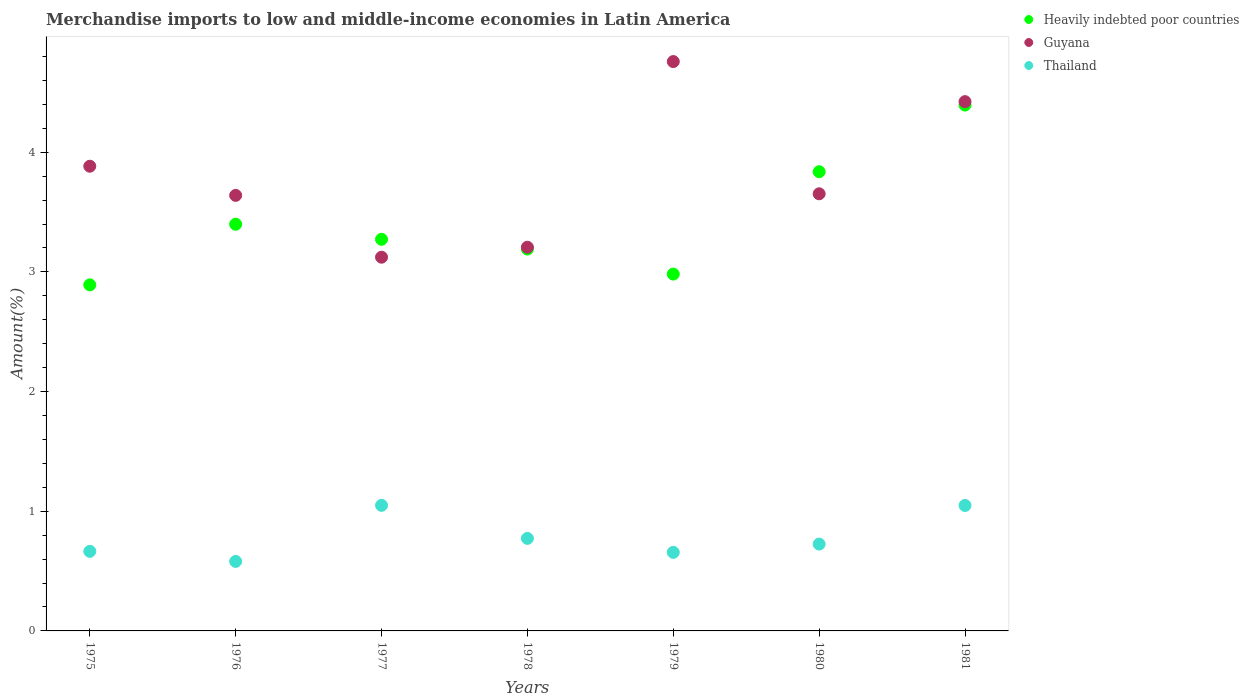How many different coloured dotlines are there?
Give a very brief answer. 3. Is the number of dotlines equal to the number of legend labels?
Ensure brevity in your answer.  Yes. What is the percentage of amount earned from merchandise imports in Heavily indebted poor countries in 1981?
Offer a terse response. 4.39. Across all years, what is the maximum percentage of amount earned from merchandise imports in Thailand?
Your answer should be compact. 1.05. Across all years, what is the minimum percentage of amount earned from merchandise imports in Thailand?
Give a very brief answer. 0.58. In which year was the percentage of amount earned from merchandise imports in Thailand maximum?
Your answer should be compact. 1977. What is the total percentage of amount earned from merchandise imports in Thailand in the graph?
Provide a short and direct response. 5.5. What is the difference between the percentage of amount earned from merchandise imports in Heavily indebted poor countries in 1979 and that in 1981?
Your answer should be very brief. -1.41. What is the difference between the percentage of amount earned from merchandise imports in Guyana in 1976 and the percentage of amount earned from merchandise imports in Thailand in 1977?
Offer a terse response. 2.59. What is the average percentage of amount earned from merchandise imports in Heavily indebted poor countries per year?
Give a very brief answer. 3.42. In the year 1979, what is the difference between the percentage of amount earned from merchandise imports in Guyana and percentage of amount earned from merchandise imports in Thailand?
Your answer should be compact. 4.1. In how many years, is the percentage of amount earned from merchandise imports in Thailand greater than 3.4 %?
Ensure brevity in your answer.  0. What is the ratio of the percentage of amount earned from merchandise imports in Thailand in 1976 to that in 1978?
Ensure brevity in your answer.  0.75. Is the percentage of amount earned from merchandise imports in Thailand in 1978 less than that in 1979?
Give a very brief answer. No. What is the difference between the highest and the second highest percentage of amount earned from merchandise imports in Thailand?
Offer a very short reply. 0. What is the difference between the highest and the lowest percentage of amount earned from merchandise imports in Guyana?
Your response must be concise. 1.63. In how many years, is the percentage of amount earned from merchandise imports in Heavily indebted poor countries greater than the average percentage of amount earned from merchandise imports in Heavily indebted poor countries taken over all years?
Provide a short and direct response. 2. Is the sum of the percentage of amount earned from merchandise imports in Guyana in 1978 and 1980 greater than the maximum percentage of amount earned from merchandise imports in Heavily indebted poor countries across all years?
Your answer should be very brief. Yes. Is the percentage of amount earned from merchandise imports in Heavily indebted poor countries strictly greater than the percentage of amount earned from merchandise imports in Thailand over the years?
Give a very brief answer. Yes. Is the percentage of amount earned from merchandise imports in Guyana strictly less than the percentage of amount earned from merchandise imports in Heavily indebted poor countries over the years?
Provide a succinct answer. No. How many dotlines are there?
Ensure brevity in your answer.  3. How many years are there in the graph?
Your answer should be very brief. 7. Are the values on the major ticks of Y-axis written in scientific E-notation?
Make the answer very short. No. Does the graph contain grids?
Offer a terse response. No. Where does the legend appear in the graph?
Provide a succinct answer. Top right. How many legend labels are there?
Your response must be concise. 3. What is the title of the graph?
Provide a short and direct response. Merchandise imports to low and middle-income economies in Latin America. What is the label or title of the X-axis?
Provide a short and direct response. Years. What is the label or title of the Y-axis?
Provide a short and direct response. Amount(%). What is the Amount(%) in Heavily indebted poor countries in 1975?
Provide a short and direct response. 2.89. What is the Amount(%) of Guyana in 1975?
Provide a short and direct response. 3.88. What is the Amount(%) in Thailand in 1975?
Provide a succinct answer. 0.66. What is the Amount(%) in Heavily indebted poor countries in 1976?
Provide a succinct answer. 3.4. What is the Amount(%) in Guyana in 1976?
Give a very brief answer. 3.64. What is the Amount(%) in Thailand in 1976?
Give a very brief answer. 0.58. What is the Amount(%) in Heavily indebted poor countries in 1977?
Provide a short and direct response. 3.27. What is the Amount(%) in Guyana in 1977?
Your response must be concise. 3.12. What is the Amount(%) of Thailand in 1977?
Offer a very short reply. 1.05. What is the Amount(%) of Heavily indebted poor countries in 1978?
Ensure brevity in your answer.  3.19. What is the Amount(%) of Guyana in 1978?
Ensure brevity in your answer.  3.21. What is the Amount(%) of Thailand in 1978?
Your answer should be compact. 0.77. What is the Amount(%) of Heavily indebted poor countries in 1979?
Give a very brief answer. 2.98. What is the Amount(%) of Guyana in 1979?
Provide a succinct answer. 4.76. What is the Amount(%) in Thailand in 1979?
Your response must be concise. 0.66. What is the Amount(%) in Heavily indebted poor countries in 1980?
Provide a succinct answer. 3.84. What is the Amount(%) in Guyana in 1980?
Your response must be concise. 3.65. What is the Amount(%) in Thailand in 1980?
Ensure brevity in your answer.  0.73. What is the Amount(%) in Heavily indebted poor countries in 1981?
Offer a terse response. 4.39. What is the Amount(%) of Guyana in 1981?
Keep it short and to the point. 4.42. What is the Amount(%) of Thailand in 1981?
Give a very brief answer. 1.05. Across all years, what is the maximum Amount(%) of Heavily indebted poor countries?
Provide a succinct answer. 4.39. Across all years, what is the maximum Amount(%) in Guyana?
Provide a short and direct response. 4.76. Across all years, what is the maximum Amount(%) in Thailand?
Give a very brief answer. 1.05. Across all years, what is the minimum Amount(%) in Heavily indebted poor countries?
Ensure brevity in your answer.  2.89. Across all years, what is the minimum Amount(%) of Guyana?
Make the answer very short. 3.12. Across all years, what is the minimum Amount(%) in Thailand?
Your response must be concise. 0.58. What is the total Amount(%) of Heavily indebted poor countries in the graph?
Offer a terse response. 23.97. What is the total Amount(%) of Guyana in the graph?
Your answer should be compact. 26.69. What is the total Amount(%) of Thailand in the graph?
Your answer should be compact. 5.5. What is the difference between the Amount(%) in Heavily indebted poor countries in 1975 and that in 1976?
Offer a terse response. -0.51. What is the difference between the Amount(%) in Guyana in 1975 and that in 1976?
Provide a succinct answer. 0.24. What is the difference between the Amount(%) of Thailand in 1975 and that in 1976?
Offer a terse response. 0.08. What is the difference between the Amount(%) of Heavily indebted poor countries in 1975 and that in 1977?
Your response must be concise. -0.38. What is the difference between the Amount(%) of Guyana in 1975 and that in 1977?
Offer a terse response. 0.76. What is the difference between the Amount(%) in Thailand in 1975 and that in 1977?
Your response must be concise. -0.38. What is the difference between the Amount(%) in Heavily indebted poor countries in 1975 and that in 1978?
Your answer should be very brief. -0.3. What is the difference between the Amount(%) in Guyana in 1975 and that in 1978?
Offer a very short reply. 0.68. What is the difference between the Amount(%) in Thailand in 1975 and that in 1978?
Provide a short and direct response. -0.11. What is the difference between the Amount(%) in Heavily indebted poor countries in 1975 and that in 1979?
Your response must be concise. -0.09. What is the difference between the Amount(%) in Guyana in 1975 and that in 1979?
Your response must be concise. -0.87. What is the difference between the Amount(%) of Thailand in 1975 and that in 1979?
Keep it short and to the point. 0.01. What is the difference between the Amount(%) in Heavily indebted poor countries in 1975 and that in 1980?
Your answer should be very brief. -0.95. What is the difference between the Amount(%) in Guyana in 1975 and that in 1980?
Offer a very short reply. 0.23. What is the difference between the Amount(%) in Thailand in 1975 and that in 1980?
Provide a succinct answer. -0.06. What is the difference between the Amount(%) of Heavily indebted poor countries in 1975 and that in 1981?
Your response must be concise. -1.5. What is the difference between the Amount(%) in Guyana in 1975 and that in 1981?
Your answer should be compact. -0.54. What is the difference between the Amount(%) of Thailand in 1975 and that in 1981?
Your answer should be very brief. -0.38. What is the difference between the Amount(%) in Heavily indebted poor countries in 1976 and that in 1977?
Ensure brevity in your answer.  0.13. What is the difference between the Amount(%) in Guyana in 1976 and that in 1977?
Your answer should be compact. 0.52. What is the difference between the Amount(%) of Thailand in 1976 and that in 1977?
Ensure brevity in your answer.  -0.47. What is the difference between the Amount(%) in Heavily indebted poor countries in 1976 and that in 1978?
Provide a succinct answer. 0.21. What is the difference between the Amount(%) of Guyana in 1976 and that in 1978?
Your response must be concise. 0.43. What is the difference between the Amount(%) in Thailand in 1976 and that in 1978?
Your answer should be very brief. -0.19. What is the difference between the Amount(%) of Heavily indebted poor countries in 1976 and that in 1979?
Keep it short and to the point. 0.42. What is the difference between the Amount(%) in Guyana in 1976 and that in 1979?
Offer a terse response. -1.12. What is the difference between the Amount(%) in Thailand in 1976 and that in 1979?
Provide a succinct answer. -0.08. What is the difference between the Amount(%) in Heavily indebted poor countries in 1976 and that in 1980?
Your response must be concise. -0.44. What is the difference between the Amount(%) of Guyana in 1976 and that in 1980?
Give a very brief answer. -0.01. What is the difference between the Amount(%) in Thailand in 1976 and that in 1980?
Give a very brief answer. -0.14. What is the difference between the Amount(%) of Heavily indebted poor countries in 1976 and that in 1981?
Your answer should be very brief. -1. What is the difference between the Amount(%) of Guyana in 1976 and that in 1981?
Your response must be concise. -0.78. What is the difference between the Amount(%) in Thailand in 1976 and that in 1981?
Provide a short and direct response. -0.47. What is the difference between the Amount(%) of Heavily indebted poor countries in 1977 and that in 1978?
Make the answer very short. 0.08. What is the difference between the Amount(%) of Guyana in 1977 and that in 1978?
Your answer should be compact. -0.08. What is the difference between the Amount(%) in Thailand in 1977 and that in 1978?
Offer a terse response. 0.28. What is the difference between the Amount(%) of Heavily indebted poor countries in 1977 and that in 1979?
Make the answer very short. 0.29. What is the difference between the Amount(%) in Guyana in 1977 and that in 1979?
Offer a very short reply. -1.63. What is the difference between the Amount(%) in Thailand in 1977 and that in 1979?
Keep it short and to the point. 0.39. What is the difference between the Amount(%) in Heavily indebted poor countries in 1977 and that in 1980?
Give a very brief answer. -0.56. What is the difference between the Amount(%) of Guyana in 1977 and that in 1980?
Offer a terse response. -0.53. What is the difference between the Amount(%) in Thailand in 1977 and that in 1980?
Your answer should be very brief. 0.32. What is the difference between the Amount(%) in Heavily indebted poor countries in 1977 and that in 1981?
Ensure brevity in your answer.  -1.12. What is the difference between the Amount(%) of Guyana in 1977 and that in 1981?
Your answer should be compact. -1.3. What is the difference between the Amount(%) in Thailand in 1977 and that in 1981?
Offer a terse response. 0. What is the difference between the Amount(%) in Heavily indebted poor countries in 1978 and that in 1979?
Keep it short and to the point. 0.21. What is the difference between the Amount(%) of Guyana in 1978 and that in 1979?
Provide a succinct answer. -1.55. What is the difference between the Amount(%) in Thailand in 1978 and that in 1979?
Keep it short and to the point. 0.12. What is the difference between the Amount(%) in Heavily indebted poor countries in 1978 and that in 1980?
Keep it short and to the point. -0.65. What is the difference between the Amount(%) in Guyana in 1978 and that in 1980?
Keep it short and to the point. -0.45. What is the difference between the Amount(%) in Thailand in 1978 and that in 1980?
Your response must be concise. 0.05. What is the difference between the Amount(%) of Heavily indebted poor countries in 1978 and that in 1981?
Provide a succinct answer. -1.2. What is the difference between the Amount(%) of Guyana in 1978 and that in 1981?
Offer a terse response. -1.22. What is the difference between the Amount(%) in Thailand in 1978 and that in 1981?
Provide a short and direct response. -0.28. What is the difference between the Amount(%) of Heavily indebted poor countries in 1979 and that in 1980?
Provide a succinct answer. -0.86. What is the difference between the Amount(%) in Guyana in 1979 and that in 1980?
Provide a succinct answer. 1.1. What is the difference between the Amount(%) of Thailand in 1979 and that in 1980?
Provide a succinct answer. -0.07. What is the difference between the Amount(%) in Heavily indebted poor countries in 1979 and that in 1981?
Ensure brevity in your answer.  -1.41. What is the difference between the Amount(%) of Guyana in 1979 and that in 1981?
Offer a terse response. 0.34. What is the difference between the Amount(%) of Thailand in 1979 and that in 1981?
Offer a terse response. -0.39. What is the difference between the Amount(%) in Heavily indebted poor countries in 1980 and that in 1981?
Provide a short and direct response. -0.56. What is the difference between the Amount(%) of Guyana in 1980 and that in 1981?
Your answer should be compact. -0.77. What is the difference between the Amount(%) of Thailand in 1980 and that in 1981?
Give a very brief answer. -0.32. What is the difference between the Amount(%) of Heavily indebted poor countries in 1975 and the Amount(%) of Guyana in 1976?
Your answer should be very brief. -0.75. What is the difference between the Amount(%) of Heavily indebted poor countries in 1975 and the Amount(%) of Thailand in 1976?
Offer a very short reply. 2.31. What is the difference between the Amount(%) of Guyana in 1975 and the Amount(%) of Thailand in 1976?
Provide a succinct answer. 3.3. What is the difference between the Amount(%) in Heavily indebted poor countries in 1975 and the Amount(%) in Guyana in 1977?
Provide a succinct answer. -0.23. What is the difference between the Amount(%) in Heavily indebted poor countries in 1975 and the Amount(%) in Thailand in 1977?
Your answer should be very brief. 1.84. What is the difference between the Amount(%) of Guyana in 1975 and the Amount(%) of Thailand in 1977?
Give a very brief answer. 2.83. What is the difference between the Amount(%) of Heavily indebted poor countries in 1975 and the Amount(%) of Guyana in 1978?
Provide a succinct answer. -0.31. What is the difference between the Amount(%) of Heavily indebted poor countries in 1975 and the Amount(%) of Thailand in 1978?
Your answer should be very brief. 2.12. What is the difference between the Amount(%) in Guyana in 1975 and the Amount(%) in Thailand in 1978?
Give a very brief answer. 3.11. What is the difference between the Amount(%) of Heavily indebted poor countries in 1975 and the Amount(%) of Guyana in 1979?
Offer a terse response. -1.87. What is the difference between the Amount(%) in Heavily indebted poor countries in 1975 and the Amount(%) in Thailand in 1979?
Give a very brief answer. 2.24. What is the difference between the Amount(%) of Guyana in 1975 and the Amount(%) of Thailand in 1979?
Your answer should be compact. 3.23. What is the difference between the Amount(%) of Heavily indebted poor countries in 1975 and the Amount(%) of Guyana in 1980?
Offer a very short reply. -0.76. What is the difference between the Amount(%) in Heavily indebted poor countries in 1975 and the Amount(%) in Thailand in 1980?
Provide a succinct answer. 2.17. What is the difference between the Amount(%) in Guyana in 1975 and the Amount(%) in Thailand in 1980?
Offer a very short reply. 3.16. What is the difference between the Amount(%) in Heavily indebted poor countries in 1975 and the Amount(%) in Guyana in 1981?
Your answer should be compact. -1.53. What is the difference between the Amount(%) of Heavily indebted poor countries in 1975 and the Amount(%) of Thailand in 1981?
Provide a short and direct response. 1.84. What is the difference between the Amount(%) of Guyana in 1975 and the Amount(%) of Thailand in 1981?
Ensure brevity in your answer.  2.83. What is the difference between the Amount(%) in Heavily indebted poor countries in 1976 and the Amount(%) in Guyana in 1977?
Your answer should be compact. 0.28. What is the difference between the Amount(%) in Heavily indebted poor countries in 1976 and the Amount(%) in Thailand in 1977?
Your response must be concise. 2.35. What is the difference between the Amount(%) in Guyana in 1976 and the Amount(%) in Thailand in 1977?
Keep it short and to the point. 2.59. What is the difference between the Amount(%) of Heavily indebted poor countries in 1976 and the Amount(%) of Guyana in 1978?
Your answer should be very brief. 0.19. What is the difference between the Amount(%) in Heavily indebted poor countries in 1976 and the Amount(%) in Thailand in 1978?
Keep it short and to the point. 2.63. What is the difference between the Amount(%) in Guyana in 1976 and the Amount(%) in Thailand in 1978?
Ensure brevity in your answer.  2.87. What is the difference between the Amount(%) of Heavily indebted poor countries in 1976 and the Amount(%) of Guyana in 1979?
Ensure brevity in your answer.  -1.36. What is the difference between the Amount(%) in Heavily indebted poor countries in 1976 and the Amount(%) in Thailand in 1979?
Your answer should be compact. 2.74. What is the difference between the Amount(%) in Guyana in 1976 and the Amount(%) in Thailand in 1979?
Offer a terse response. 2.98. What is the difference between the Amount(%) of Heavily indebted poor countries in 1976 and the Amount(%) of Guyana in 1980?
Keep it short and to the point. -0.25. What is the difference between the Amount(%) in Heavily indebted poor countries in 1976 and the Amount(%) in Thailand in 1980?
Offer a very short reply. 2.67. What is the difference between the Amount(%) in Guyana in 1976 and the Amount(%) in Thailand in 1980?
Provide a short and direct response. 2.91. What is the difference between the Amount(%) of Heavily indebted poor countries in 1976 and the Amount(%) of Guyana in 1981?
Provide a succinct answer. -1.02. What is the difference between the Amount(%) of Heavily indebted poor countries in 1976 and the Amount(%) of Thailand in 1981?
Keep it short and to the point. 2.35. What is the difference between the Amount(%) of Guyana in 1976 and the Amount(%) of Thailand in 1981?
Your response must be concise. 2.59. What is the difference between the Amount(%) of Heavily indebted poor countries in 1977 and the Amount(%) of Guyana in 1978?
Make the answer very short. 0.07. What is the difference between the Amount(%) of Heavily indebted poor countries in 1977 and the Amount(%) of Thailand in 1978?
Your response must be concise. 2.5. What is the difference between the Amount(%) in Guyana in 1977 and the Amount(%) in Thailand in 1978?
Your response must be concise. 2.35. What is the difference between the Amount(%) in Heavily indebted poor countries in 1977 and the Amount(%) in Guyana in 1979?
Your answer should be compact. -1.49. What is the difference between the Amount(%) of Heavily indebted poor countries in 1977 and the Amount(%) of Thailand in 1979?
Give a very brief answer. 2.62. What is the difference between the Amount(%) in Guyana in 1977 and the Amount(%) in Thailand in 1979?
Give a very brief answer. 2.47. What is the difference between the Amount(%) of Heavily indebted poor countries in 1977 and the Amount(%) of Guyana in 1980?
Give a very brief answer. -0.38. What is the difference between the Amount(%) of Heavily indebted poor countries in 1977 and the Amount(%) of Thailand in 1980?
Your answer should be compact. 2.55. What is the difference between the Amount(%) of Guyana in 1977 and the Amount(%) of Thailand in 1980?
Make the answer very short. 2.4. What is the difference between the Amount(%) in Heavily indebted poor countries in 1977 and the Amount(%) in Guyana in 1981?
Make the answer very short. -1.15. What is the difference between the Amount(%) in Heavily indebted poor countries in 1977 and the Amount(%) in Thailand in 1981?
Offer a very short reply. 2.22. What is the difference between the Amount(%) in Guyana in 1977 and the Amount(%) in Thailand in 1981?
Your response must be concise. 2.07. What is the difference between the Amount(%) of Heavily indebted poor countries in 1978 and the Amount(%) of Guyana in 1979?
Your response must be concise. -1.57. What is the difference between the Amount(%) of Heavily indebted poor countries in 1978 and the Amount(%) of Thailand in 1979?
Your answer should be compact. 2.53. What is the difference between the Amount(%) of Guyana in 1978 and the Amount(%) of Thailand in 1979?
Make the answer very short. 2.55. What is the difference between the Amount(%) of Heavily indebted poor countries in 1978 and the Amount(%) of Guyana in 1980?
Your response must be concise. -0.46. What is the difference between the Amount(%) in Heavily indebted poor countries in 1978 and the Amount(%) in Thailand in 1980?
Give a very brief answer. 2.47. What is the difference between the Amount(%) in Guyana in 1978 and the Amount(%) in Thailand in 1980?
Your answer should be compact. 2.48. What is the difference between the Amount(%) of Heavily indebted poor countries in 1978 and the Amount(%) of Guyana in 1981?
Keep it short and to the point. -1.23. What is the difference between the Amount(%) of Heavily indebted poor countries in 1978 and the Amount(%) of Thailand in 1981?
Offer a terse response. 2.14. What is the difference between the Amount(%) in Guyana in 1978 and the Amount(%) in Thailand in 1981?
Offer a very short reply. 2.16. What is the difference between the Amount(%) in Heavily indebted poor countries in 1979 and the Amount(%) in Guyana in 1980?
Offer a terse response. -0.67. What is the difference between the Amount(%) of Heavily indebted poor countries in 1979 and the Amount(%) of Thailand in 1980?
Ensure brevity in your answer.  2.26. What is the difference between the Amount(%) in Guyana in 1979 and the Amount(%) in Thailand in 1980?
Offer a very short reply. 4.03. What is the difference between the Amount(%) in Heavily indebted poor countries in 1979 and the Amount(%) in Guyana in 1981?
Provide a short and direct response. -1.44. What is the difference between the Amount(%) of Heavily indebted poor countries in 1979 and the Amount(%) of Thailand in 1981?
Provide a succinct answer. 1.93. What is the difference between the Amount(%) of Guyana in 1979 and the Amount(%) of Thailand in 1981?
Provide a succinct answer. 3.71. What is the difference between the Amount(%) of Heavily indebted poor countries in 1980 and the Amount(%) of Guyana in 1981?
Give a very brief answer. -0.59. What is the difference between the Amount(%) of Heavily indebted poor countries in 1980 and the Amount(%) of Thailand in 1981?
Your answer should be compact. 2.79. What is the difference between the Amount(%) of Guyana in 1980 and the Amount(%) of Thailand in 1981?
Offer a terse response. 2.6. What is the average Amount(%) of Heavily indebted poor countries per year?
Provide a succinct answer. 3.42. What is the average Amount(%) of Guyana per year?
Your answer should be very brief. 3.81. What is the average Amount(%) in Thailand per year?
Ensure brevity in your answer.  0.79. In the year 1975, what is the difference between the Amount(%) in Heavily indebted poor countries and Amount(%) in Guyana?
Provide a succinct answer. -0.99. In the year 1975, what is the difference between the Amount(%) in Heavily indebted poor countries and Amount(%) in Thailand?
Keep it short and to the point. 2.23. In the year 1975, what is the difference between the Amount(%) of Guyana and Amount(%) of Thailand?
Ensure brevity in your answer.  3.22. In the year 1976, what is the difference between the Amount(%) of Heavily indebted poor countries and Amount(%) of Guyana?
Ensure brevity in your answer.  -0.24. In the year 1976, what is the difference between the Amount(%) of Heavily indebted poor countries and Amount(%) of Thailand?
Your answer should be very brief. 2.82. In the year 1976, what is the difference between the Amount(%) in Guyana and Amount(%) in Thailand?
Provide a succinct answer. 3.06. In the year 1977, what is the difference between the Amount(%) in Heavily indebted poor countries and Amount(%) in Guyana?
Your response must be concise. 0.15. In the year 1977, what is the difference between the Amount(%) in Heavily indebted poor countries and Amount(%) in Thailand?
Offer a very short reply. 2.22. In the year 1977, what is the difference between the Amount(%) in Guyana and Amount(%) in Thailand?
Your response must be concise. 2.07. In the year 1978, what is the difference between the Amount(%) of Heavily indebted poor countries and Amount(%) of Guyana?
Ensure brevity in your answer.  -0.02. In the year 1978, what is the difference between the Amount(%) of Heavily indebted poor countries and Amount(%) of Thailand?
Make the answer very short. 2.42. In the year 1978, what is the difference between the Amount(%) of Guyana and Amount(%) of Thailand?
Your response must be concise. 2.43. In the year 1979, what is the difference between the Amount(%) of Heavily indebted poor countries and Amount(%) of Guyana?
Your answer should be very brief. -1.78. In the year 1979, what is the difference between the Amount(%) of Heavily indebted poor countries and Amount(%) of Thailand?
Provide a succinct answer. 2.33. In the year 1979, what is the difference between the Amount(%) of Guyana and Amount(%) of Thailand?
Your answer should be compact. 4.1. In the year 1980, what is the difference between the Amount(%) in Heavily indebted poor countries and Amount(%) in Guyana?
Ensure brevity in your answer.  0.18. In the year 1980, what is the difference between the Amount(%) of Heavily indebted poor countries and Amount(%) of Thailand?
Provide a succinct answer. 3.11. In the year 1980, what is the difference between the Amount(%) of Guyana and Amount(%) of Thailand?
Offer a terse response. 2.93. In the year 1981, what is the difference between the Amount(%) in Heavily indebted poor countries and Amount(%) in Guyana?
Ensure brevity in your answer.  -0.03. In the year 1981, what is the difference between the Amount(%) in Heavily indebted poor countries and Amount(%) in Thailand?
Offer a very short reply. 3.35. In the year 1981, what is the difference between the Amount(%) of Guyana and Amount(%) of Thailand?
Give a very brief answer. 3.37. What is the ratio of the Amount(%) of Heavily indebted poor countries in 1975 to that in 1976?
Your answer should be compact. 0.85. What is the ratio of the Amount(%) in Guyana in 1975 to that in 1976?
Provide a short and direct response. 1.07. What is the ratio of the Amount(%) of Thailand in 1975 to that in 1976?
Your answer should be very brief. 1.14. What is the ratio of the Amount(%) in Heavily indebted poor countries in 1975 to that in 1977?
Your answer should be compact. 0.88. What is the ratio of the Amount(%) in Guyana in 1975 to that in 1977?
Your response must be concise. 1.24. What is the ratio of the Amount(%) of Thailand in 1975 to that in 1977?
Offer a terse response. 0.63. What is the ratio of the Amount(%) of Heavily indebted poor countries in 1975 to that in 1978?
Give a very brief answer. 0.91. What is the ratio of the Amount(%) of Guyana in 1975 to that in 1978?
Provide a succinct answer. 1.21. What is the ratio of the Amount(%) of Thailand in 1975 to that in 1978?
Provide a succinct answer. 0.86. What is the ratio of the Amount(%) of Heavily indebted poor countries in 1975 to that in 1979?
Your answer should be compact. 0.97. What is the ratio of the Amount(%) of Guyana in 1975 to that in 1979?
Provide a short and direct response. 0.82. What is the ratio of the Amount(%) in Thailand in 1975 to that in 1979?
Give a very brief answer. 1.01. What is the ratio of the Amount(%) in Heavily indebted poor countries in 1975 to that in 1980?
Provide a short and direct response. 0.75. What is the ratio of the Amount(%) in Guyana in 1975 to that in 1980?
Make the answer very short. 1.06. What is the ratio of the Amount(%) of Thailand in 1975 to that in 1980?
Give a very brief answer. 0.92. What is the ratio of the Amount(%) in Heavily indebted poor countries in 1975 to that in 1981?
Make the answer very short. 0.66. What is the ratio of the Amount(%) in Guyana in 1975 to that in 1981?
Make the answer very short. 0.88. What is the ratio of the Amount(%) of Thailand in 1975 to that in 1981?
Your response must be concise. 0.63. What is the ratio of the Amount(%) in Heavily indebted poor countries in 1976 to that in 1977?
Ensure brevity in your answer.  1.04. What is the ratio of the Amount(%) in Guyana in 1976 to that in 1977?
Ensure brevity in your answer.  1.17. What is the ratio of the Amount(%) in Thailand in 1976 to that in 1977?
Ensure brevity in your answer.  0.55. What is the ratio of the Amount(%) in Heavily indebted poor countries in 1976 to that in 1978?
Offer a very short reply. 1.06. What is the ratio of the Amount(%) in Guyana in 1976 to that in 1978?
Offer a very short reply. 1.14. What is the ratio of the Amount(%) in Thailand in 1976 to that in 1978?
Keep it short and to the point. 0.75. What is the ratio of the Amount(%) of Heavily indebted poor countries in 1976 to that in 1979?
Your answer should be very brief. 1.14. What is the ratio of the Amount(%) in Guyana in 1976 to that in 1979?
Your answer should be very brief. 0.77. What is the ratio of the Amount(%) of Thailand in 1976 to that in 1979?
Keep it short and to the point. 0.88. What is the ratio of the Amount(%) of Heavily indebted poor countries in 1976 to that in 1980?
Give a very brief answer. 0.89. What is the ratio of the Amount(%) in Thailand in 1976 to that in 1980?
Your response must be concise. 0.8. What is the ratio of the Amount(%) of Heavily indebted poor countries in 1976 to that in 1981?
Provide a succinct answer. 0.77. What is the ratio of the Amount(%) of Guyana in 1976 to that in 1981?
Offer a very short reply. 0.82. What is the ratio of the Amount(%) in Thailand in 1976 to that in 1981?
Provide a short and direct response. 0.55. What is the ratio of the Amount(%) in Heavily indebted poor countries in 1977 to that in 1978?
Offer a very short reply. 1.03. What is the ratio of the Amount(%) in Guyana in 1977 to that in 1978?
Your answer should be compact. 0.97. What is the ratio of the Amount(%) of Thailand in 1977 to that in 1978?
Keep it short and to the point. 1.36. What is the ratio of the Amount(%) of Heavily indebted poor countries in 1977 to that in 1979?
Provide a short and direct response. 1.1. What is the ratio of the Amount(%) in Guyana in 1977 to that in 1979?
Make the answer very short. 0.66. What is the ratio of the Amount(%) in Thailand in 1977 to that in 1979?
Keep it short and to the point. 1.6. What is the ratio of the Amount(%) of Heavily indebted poor countries in 1977 to that in 1980?
Provide a short and direct response. 0.85. What is the ratio of the Amount(%) of Guyana in 1977 to that in 1980?
Your answer should be very brief. 0.85. What is the ratio of the Amount(%) in Thailand in 1977 to that in 1980?
Provide a succinct answer. 1.45. What is the ratio of the Amount(%) of Heavily indebted poor countries in 1977 to that in 1981?
Offer a terse response. 0.74. What is the ratio of the Amount(%) of Guyana in 1977 to that in 1981?
Your answer should be very brief. 0.71. What is the ratio of the Amount(%) in Heavily indebted poor countries in 1978 to that in 1979?
Offer a very short reply. 1.07. What is the ratio of the Amount(%) in Guyana in 1978 to that in 1979?
Keep it short and to the point. 0.67. What is the ratio of the Amount(%) in Thailand in 1978 to that in 1979?
Ensure brevity in your answer.  1.18. What is the ratio of the Amount(%) in Heavily indebted poor countries in 1978 to that in 1980?
Make the answer very short. 0.83. What is the ratio of the Amount(%) in Guyana in 1978 to that in 1980?
Your answer should be compact. 0.88. What is the ratio of the Amount(%) in Thailand in 1978 to that in 1980?
Provide a short and direct response. 1.07. What is the ratio of the Amount(%) in Heavily indebted poor countries in 1978 to that in 1981?
Your answer should be very brief. 0.73. What is the ratio of the Amount(%) in Guyana in 1978 to that in 1981?
Provide a short and direct response. 0.72. What is the ratio of the Amount(%) of Thailand in 1978 to that in 1981?
Your response must be concise. 0.74. What is the ratio of the Amount(%) of Heavily indebted poor countries in 1979 to that in 1980?
Provide a succinct answer. 0.78. What is the ratio of the Amount(%) of Guyana in 1979 to that in 1980?
Give a very brief answer. 1.3. What is the ratio of the Amount(%) of Thailand in 1979 to that in 1980?
Make the answer very short. 0.9. What is the ratio of the Amount(%) in Heavily indebted poor countries in 1979 to that in 1981?
Ensure brevity in your answer.  0.68. What is the ratio of the Amount(%) in Guyana in 1979 to that in 1981?
Keep it short and to the point. 1.08. What is the ratio of the Amount(%) in Thailand in 1979 to that in 1981?
Make the answer very short. 0.63. What is the ratio of the Amount(%) of Heavily indebted poor countries in 1980 to that in 1981?
Your answer should be very brief. 0.87. What is the ratio of the Amount(%) in Guyana in 1980 to that in 1981?
Provide a short and direct response. 0.83. What is the ratio of the Amount(%) of Thailand in 1980 to that in 1981?
Keep it short and to the point. 0.69. What is the difference between the highest and the second highest Amount(%) in Heavily indebted poor countries?
Offer a terse response. 0.56. What is the difference between the highest and the second highest Amount(%) of Guyana?
Your answer should be very brief. 0.34. What is the difference between the highest and the second highest Amount(%) of Thailand?
Your answer should be very brief. 0. What is the difference between the highest and the lowest Amount(%) of Heavily indebted poor countries?
Give a very brief answer. 1.5. What is the difference between the highest and the lowest Amount(%) of Guyana?
Your response must be concise. 1.63. What is the difference between the highest and the lowest Amount(%) in Thailand?
Your response must be concise. 0.47. 